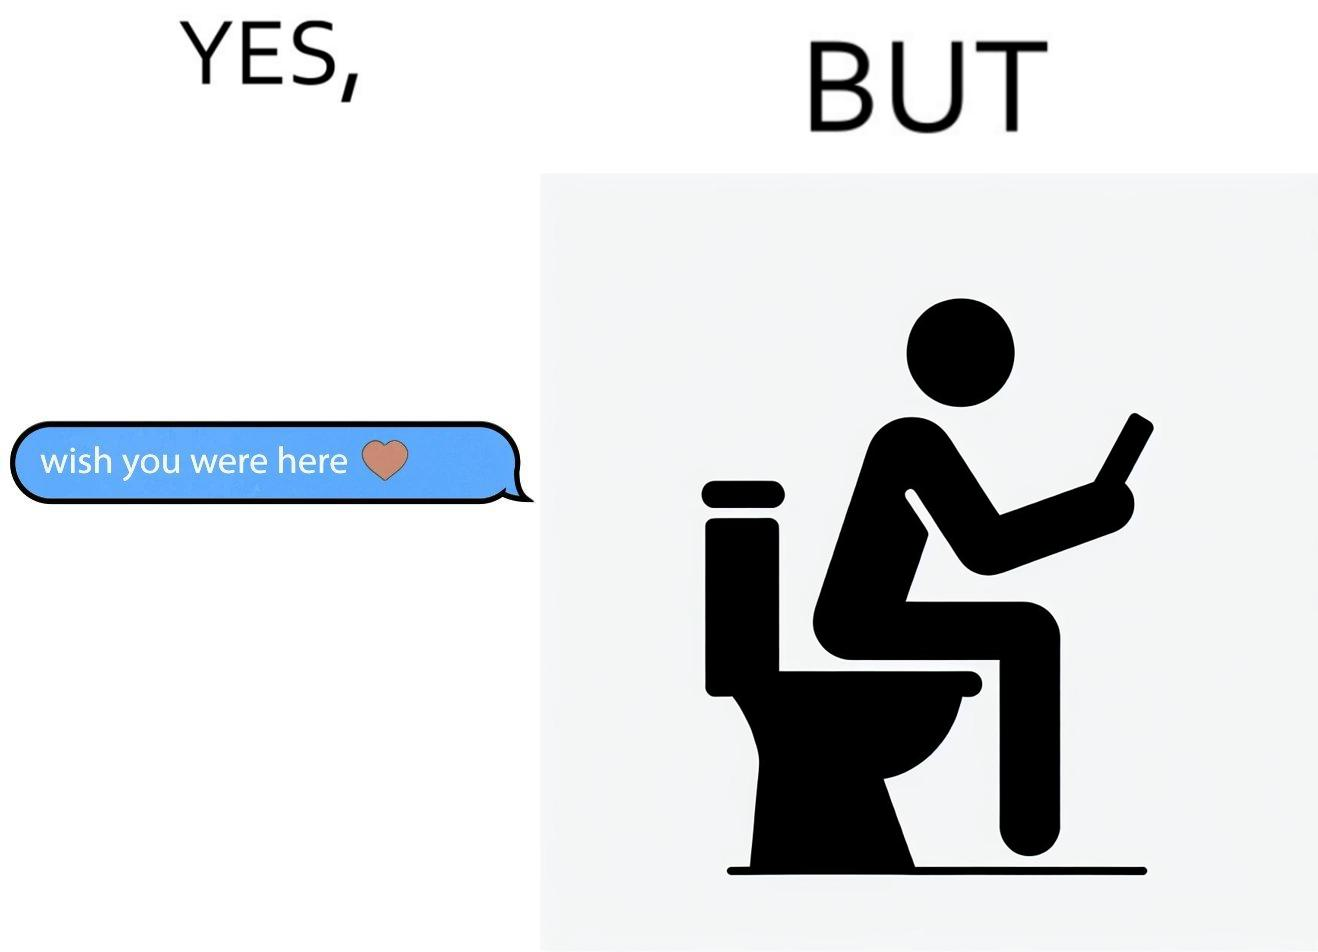Describe the satirical element in this image. The images are funny since it shows how even though a man writes to his partner that he wishes she was there to show that he misses her, it would be inappropriate and gross if it were to happen literally as he is sitting on his toilet 